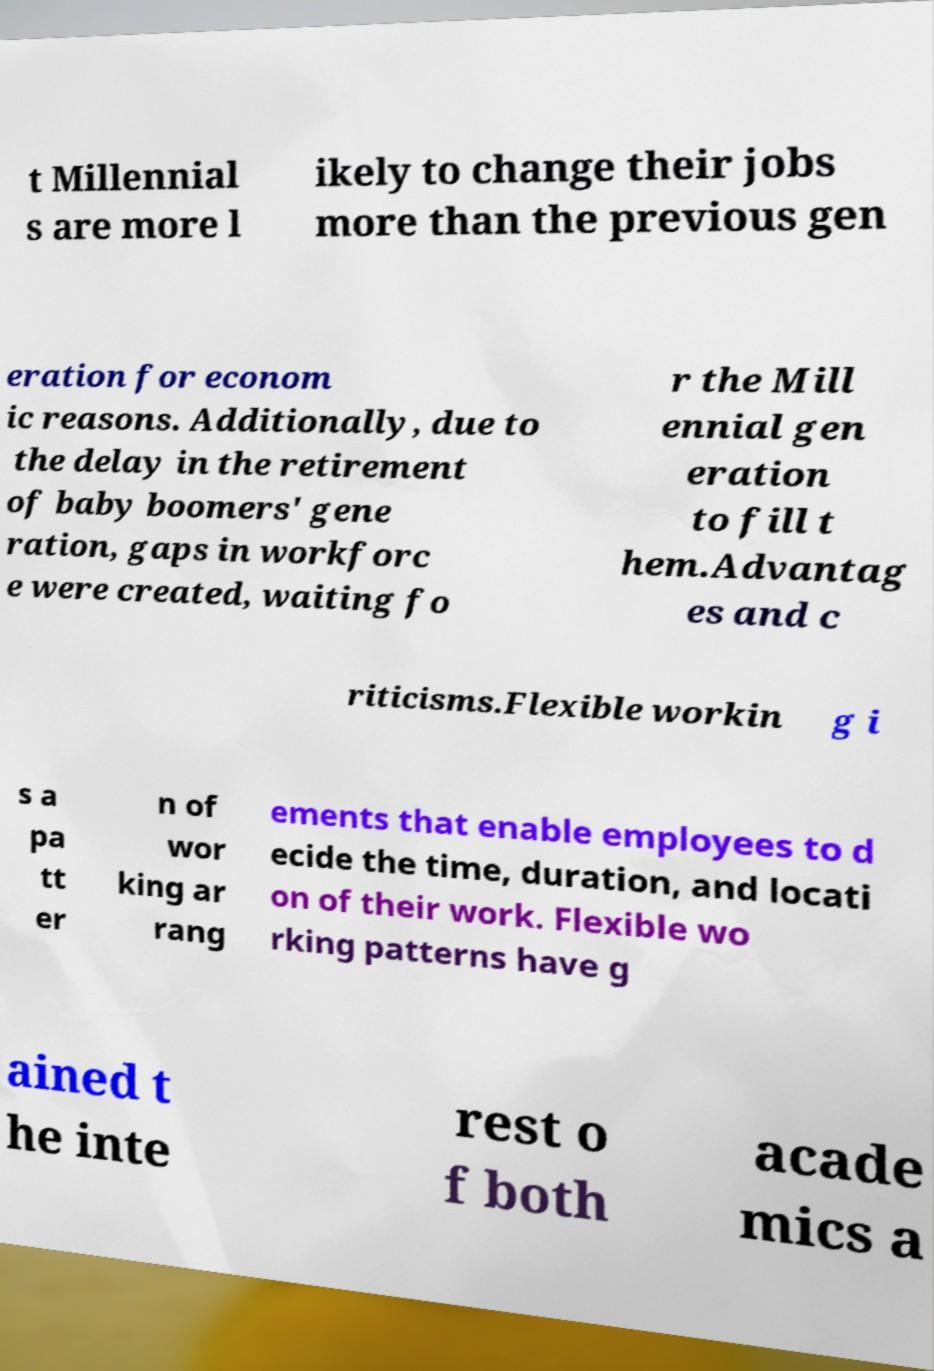There's text embedded in this image that I need extracted. Can you transcribe it verbatim? t Millennial s are more l ikely to change their jobs more than the previous gen eration for econom ic reasons. Additionally, due to the delay in the retirement of baby boomers' gene ration, gaps in workforc e were created, waiting fo r the Mill ennial gen eration to fill t hem.Advantag es and c riticisms.Flexible workin g i s a pa tt er n of wor king ar rang ements that enable employees to d ecide the time, duration, and locati on of their work. Flexible wo rking patterns have g ained t he inte rest o f both acade mics a 